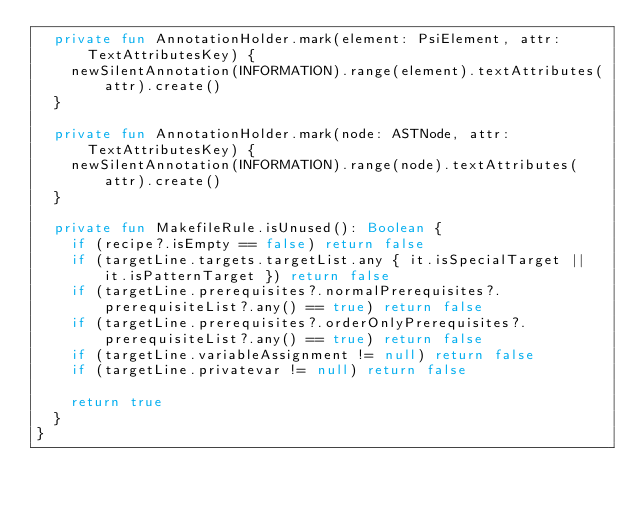<code> <loc_0><loc_0><loc_500><loc_500><_Kotlin_>  private fun AnnotationHolder.mark(element: PsiElement, attr: TextAttributesKey) {
    newSilentAnnotation(INFORMATION).range(element).textAttributes(attr).create()
  }

  private fun AnnotationHolder.mark(node: ASTNode, attr: TextAttributesKey) {
    newSilentAnnotation(INFORMATION).range(node).textAttributes(attr).create()
  }

  private fun MakefileRule.isUnused(): Boolean {
    if (recipe?.isEmpty == false) return false
    if (targetLine.targets.targetList.any { it.isSpecialTarget || it.isPatternTarget }) return false
    if (targetLine.prerequisites?.normalPrerequisites?.prerequisiteList?.any() == true) return false
    if (targetLine.prerequisites?.orderOnlyPrerequisites?.prerequisiteList?.any() == true) return false
    if (targetLine.variableAssignment != null) return false
    if (targetLine.privatevar != null) return false

    return true
  }
}</code> 